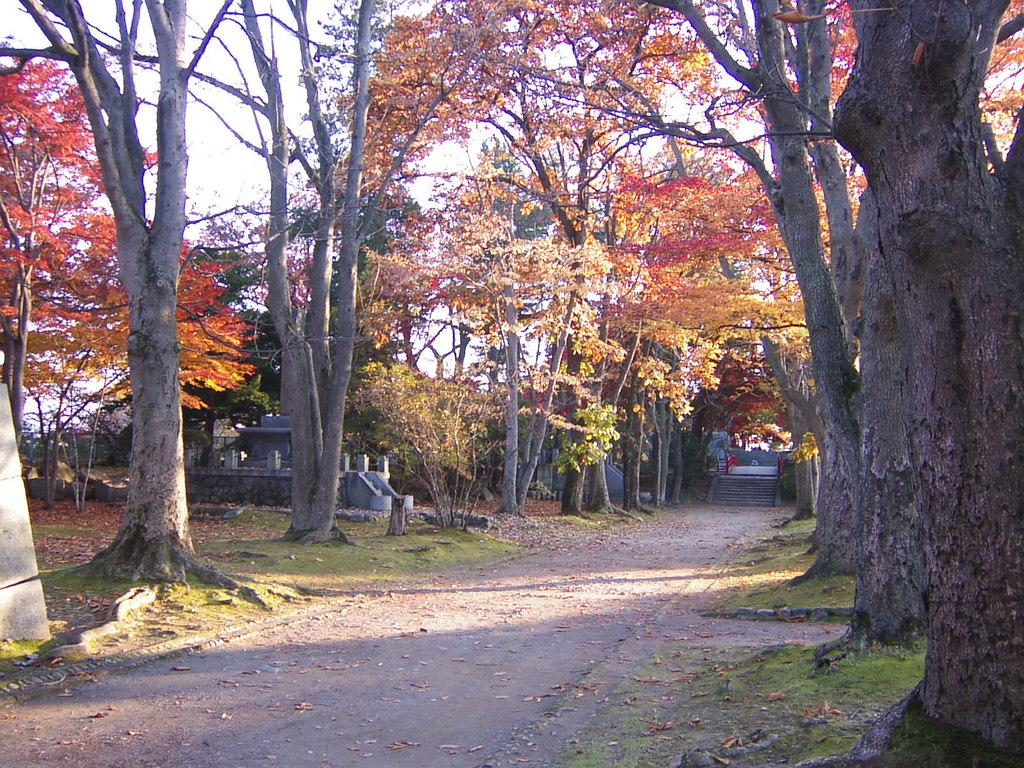What type of vegetation can be seen in the image? There are trees in the image. What part of the trees can be seen in the image? There are leaves in the image. What type of man-made structures are present in the image? There are buildings in the image. What type of transportation infrastructure is present in the image? There is a road in the image. What part of the natural environment is visible in the image? The sky is visible in the background of the image. What type of window can be seen in the image? There is no window present in the image. What type of sugar is used to sweeten the paste in the image? There is no sugar or paste present in the image. 